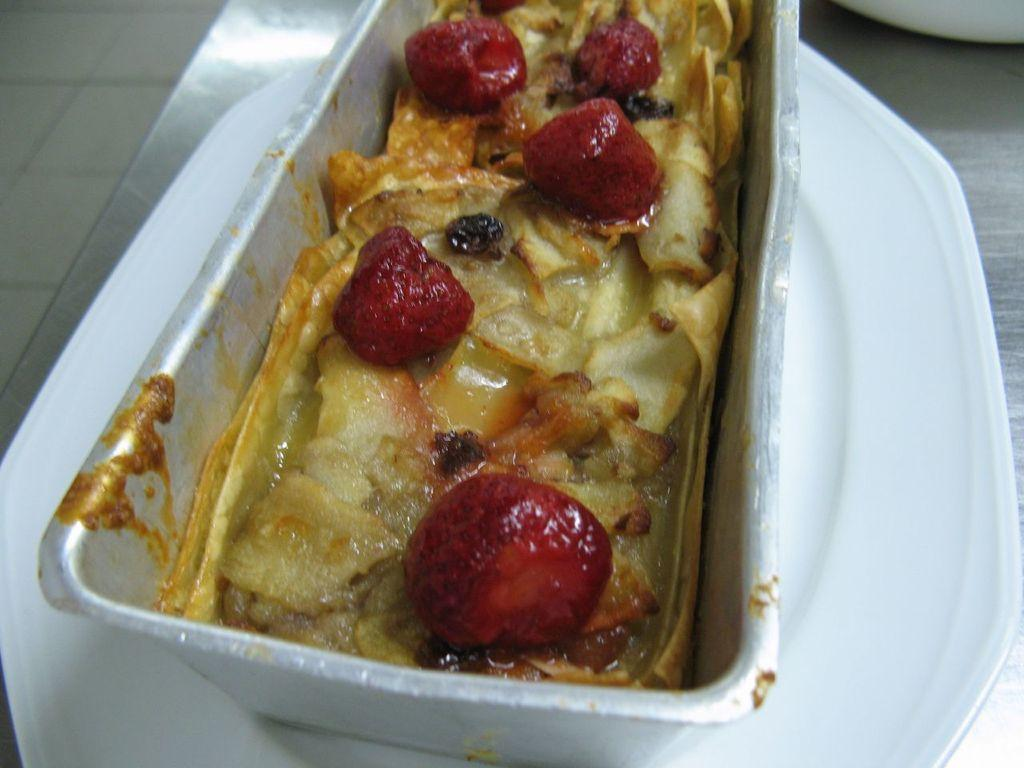What is the main object in the center of the image? There is a plate in the center of the image. What is placed on the plate? There is a box on the plate. What is inside the box? There is food inside the box. What is the surface on which the plate is placed? There is a table at the bottom of the image. Can you see any mist surrounding the food in the image? There is no mist present in the image. How many pizzas are visible on the plate? There are no pizzas visible in the image; it features a box with food on a plate. 